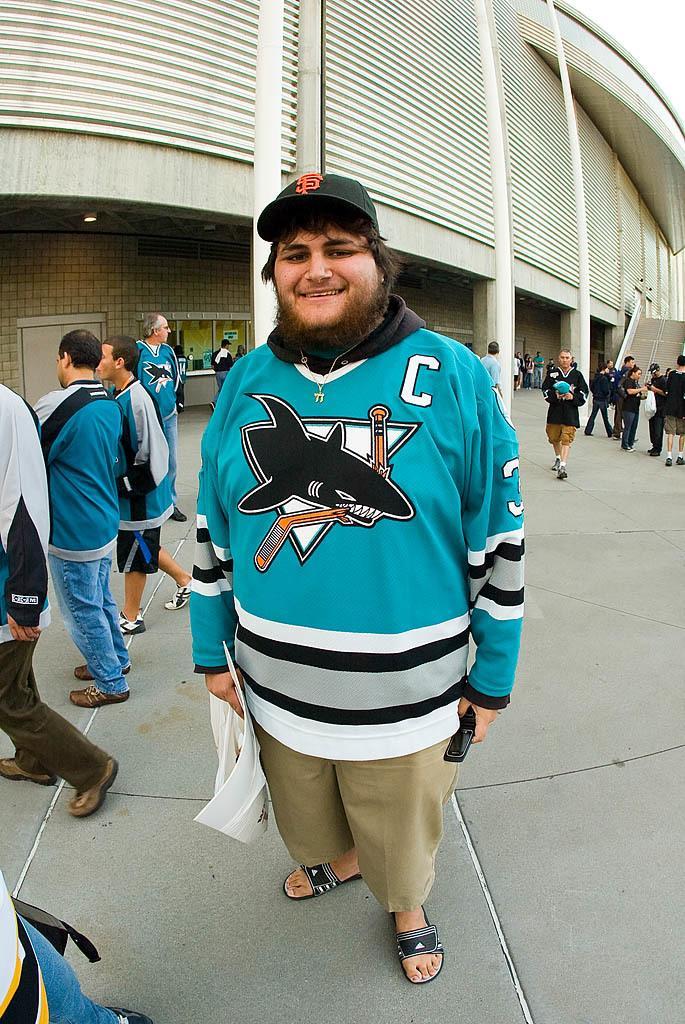Describe this image in one or two sentences. In the foreground of the picture there is a person standing. On the left we can see people walking. On the right there are people. In the middle of the picture we can see people walking. In the background there is a building. At the top right corner we can see sky. 